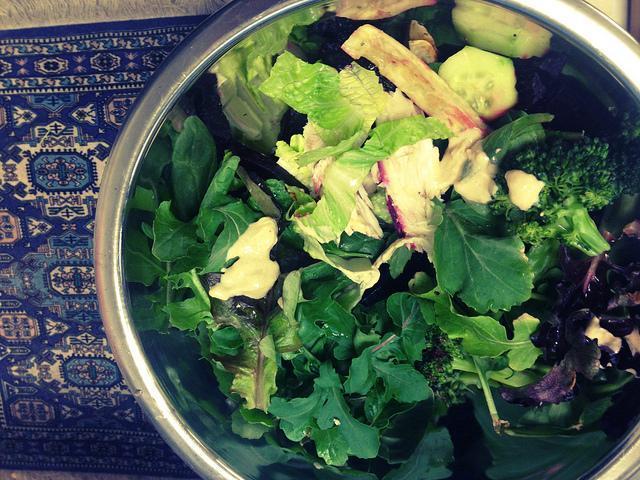How many broccolis are there?
Give a very brief answer. 2. How many people have their hands showing?
Give a very brief answer. 0. 